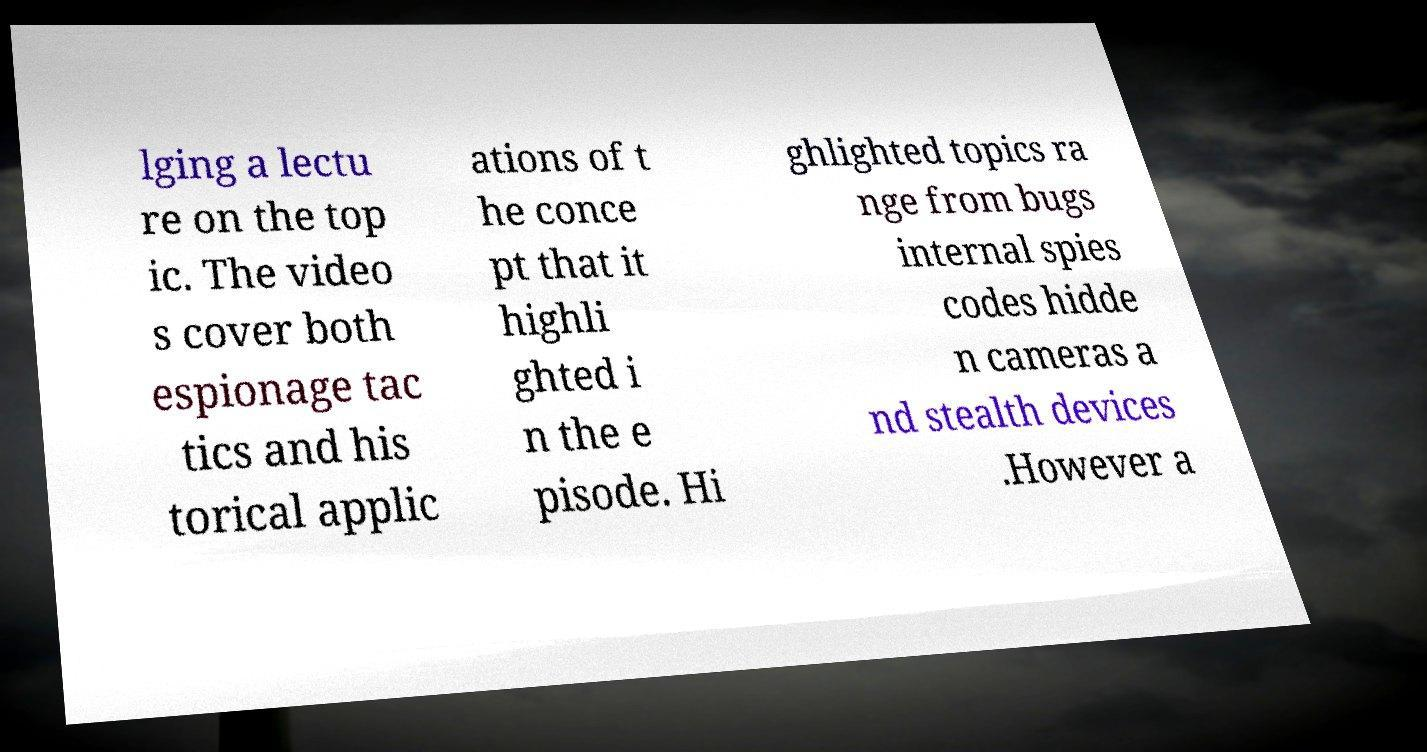Can you accurately transcribe the text from the provided image for me? lging a lectu re on the top ic. The video s cover both espionage tac tics and his torical applic ations of t he conce pt that it highli ghted i n the e pisode. Hi ghlighted topics ra nge from bugs internal spies codes hidde n cameras a nd stealth devices .However a 